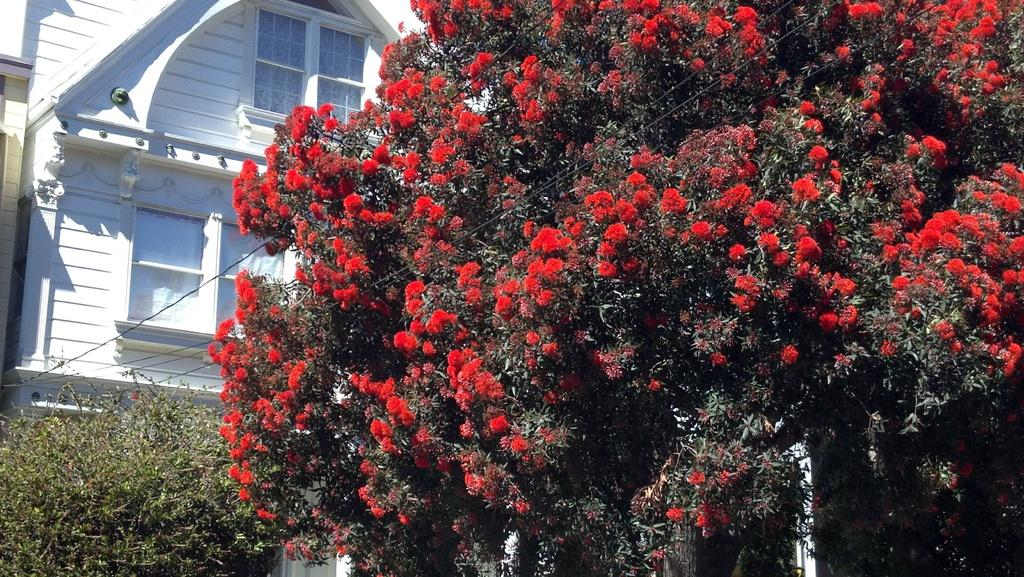What type of flowers can be seen on the trees in the image? The trees in the image have red color flowers. What other types of plants are present in the image? There are shrubs in the image. What can be seen in the background of the image? There is a white color house in the background of the image. Can you describe the creaminess of the flowers on the trees in the image? The flowers on the trees in the image are not creamy; they are red color flowers. 